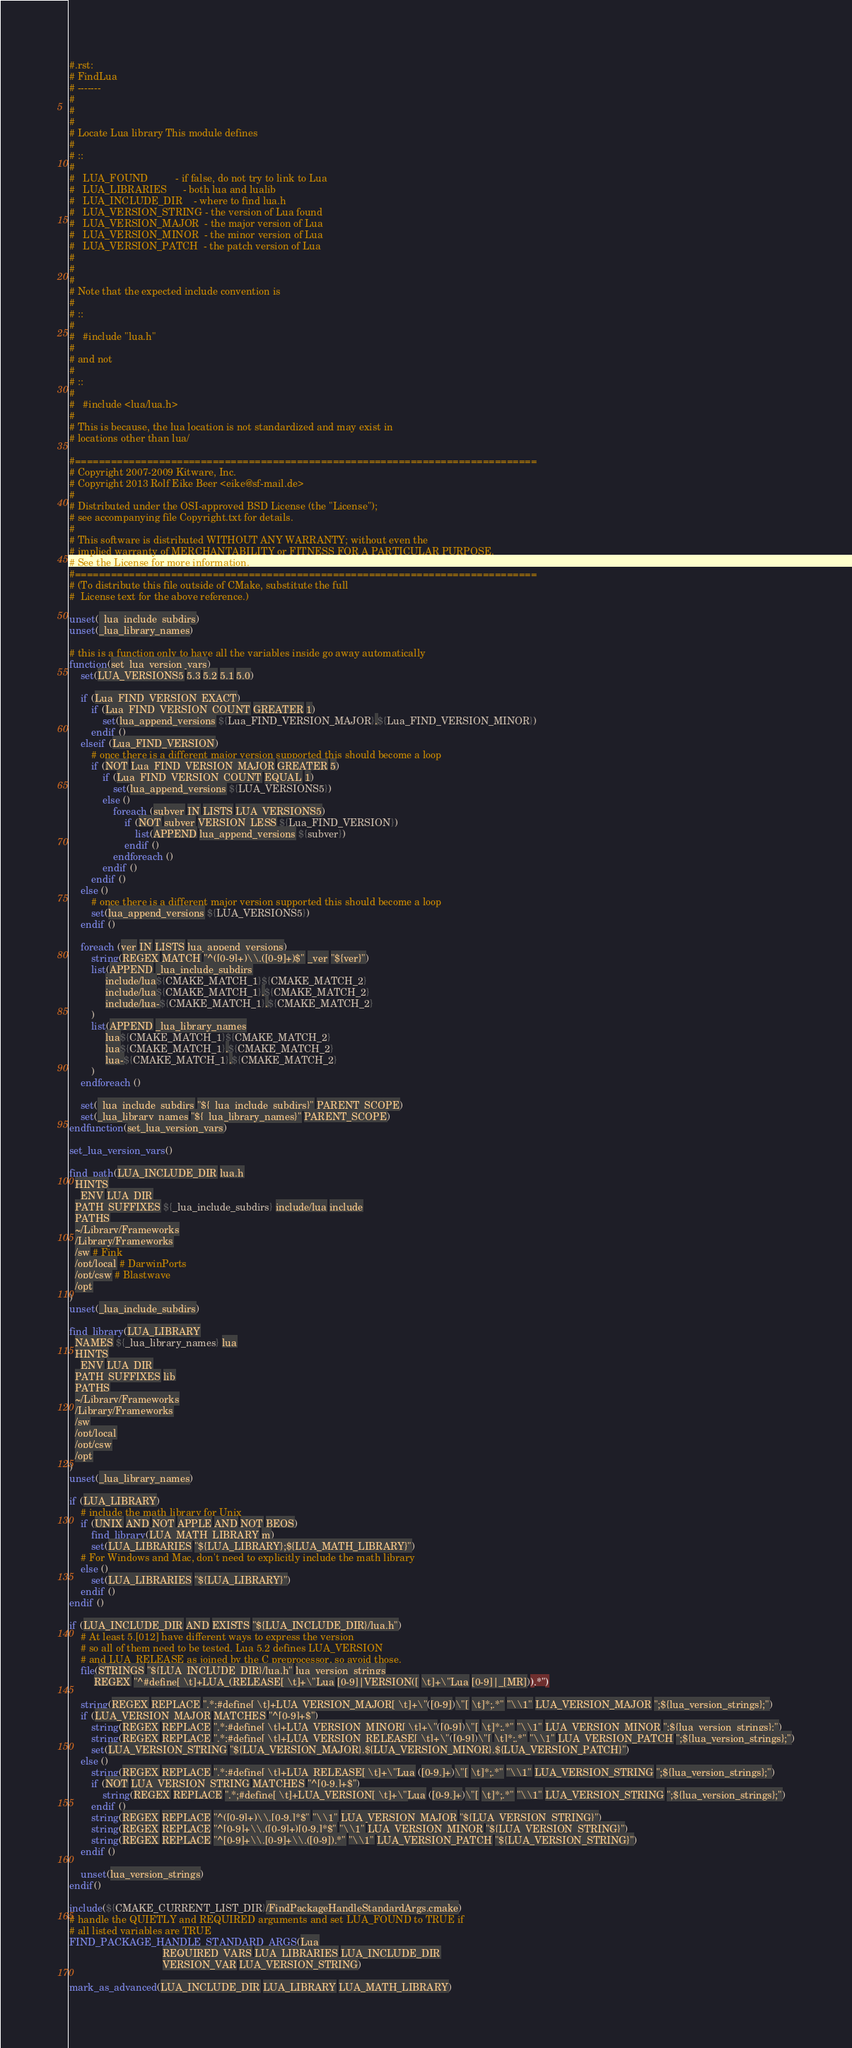Convert code to text. <code><loc_0><loc_0><loc_500><loc_500><_CMake_>#.rst:
# FindLua
# -------
#
#
#
# Locate Lua library This module defines
#
# ::
#
#   LUA_FOUND          - if false, do not try to link to Lua
#   LUA_LIBRARIES      - both lua and lualib
#   LUA_INCLUDE_DIR    - where to find lua.h
#   LUA_VERSION_STRING - the version of Lua found
#   LUA_VERSION_MAJOR  - the major version of Lua
#   LUA_VERSION_MINOR  - the minor version of Lua
#   LUA_VERSION_PATCH  - the patch version of Lua
#
#
#
# Note that the expected include convention is
#
# ::
#
#   #include "lua.h"
#
# and not
#
# ::
#
#   #include <lua/lua.h>
#
# This is because, the lua location is not standardized and may exist in
# locations other than lua/

#=============================================================================
# Copyright 2007-2009 Kitware, Inc.
# Copyright 2013 Rolf Eike Beer <eike@sf-mail.de>
#
# Distributed under the OSI-approved BSD License (the "License");
# see accompanying file Copyright.txt for details.
#
# This software is distributed WITHOUT ANY WARRANTY; without even the
# implied warranty of MERCHANTABILITY or FITNESS FOR A PARTICULAR PURPOSE.
# See the License for more information.
#=============================================================================
# (To distribute this file outside of CMake, substitute the full
#  License text for the above reference.)

unset(_lua_include_subdirs)
unset(_lua_library_names)

# this is a function only to have all the variables inside go away automatically
function(set_lua_version_vars)
    set(LUA_VERSIONS5 5.3 5.2 5.1 5.0)

    if (Lua_FIND_VERSION_EXACT)
        if (Lua_FIND_VERSION_COUNT GREATER 1)
            set(lua_append_versions ${Lua_FIND_VERSION_MAJOR}.${Lua_FIND_VERSION_MINOR})
        endif ()
    elseif (Lua_FIND_VERSION)
        # once there is a different major version supported this should become a loop
        if (NOT Lua_FIND_VERSION_MAJOR GREATER 5)
            if (Lua_FIND_VERSION_COUNT EQUAL 1)
                set(lua_append_versions ${LUA_VERSIONS5})
            else ()
                foreach (subver IN LISTS LUA_VERSIONS5)
                    if (NOT subver VERSION_LESS ${Lua_FIND_VERSION})
                        list(APPEND lua_append_versions ${subver})
                    endif ()
                endforeach ()
            endif ()
        endif ()
    else ()
        # once there is a different major version supported this should become a loop
        set(lua_append_versions ${LUA_VERSIONS5})
    endif ()

    foreach (ver IN LISTS lua_append_versions)
        string(REGEX MATCH "^([0-9]+)\\.([0-9]+)$" _ver "${ver}")
        list(APPEND _lua_include_subdirs
             include/lua${CMAKE_MATCH_1}${CMAKE_MATCH_2}
             include/lua${CMAKE_MATCH_1}.${CMAKE_MATCH_2}
             include/lua-${CMAKE_MATCH_1}.${CMAKE_MATCH_2}
        )
        list(APPEND _lua_library_names
             lua${CMAKE_MATCH_1}${CMAKE_MATCH_2}
             lua${CMAKE_MATCH_1}.${CMAKE_MATCH_2}
             lua-${CMAKE_MATCH_1}.${CMAKE_MATCH_2}
        )
    endforeach ()

    set(_lua_include_subdirs "${_lua_include_subdirs}" PARENT_SCOPE)
    set(_lua_library_names "${_lua_library_names}" PARENT_SCOPE)
endfunction(set_lua_version_vars)

set_lua_version_vars()

find_path(LUA_INCLUDE_DIR lua.h
  HINTS
    ENV LUA_DIR
  PATH_SUFFIXES ${_lua_include_subdirs} include/lua include
  PATHS
  ~/Library/Frameworks
  /Library/Frameworks
  /sw # Fink
  /opt/local # DarwinPorts
  /opt/csw # Blastwave
  /opt
)
unset(_lua_include_subdirs)

find_library(LUA_LIBRARY
  NAMES ${_lua_library_names} lua
  HINTS
    ENV LUA_DIR
  PATH_SUFFIXES lib
  PATHS
  ~/Library/Frameworks
  /Library/Frameworks
  /sw
  /opt/local
  /opt/csw
  /opt
)
unset(_lua_library_names)

if (LUA_LIBRARY)
    # include the math library for Unix
    if (UNIX AND NOT APPLE AND NOT BEOS)
        find_library(LUA_MATH_LIBRARY m)
        set(LUA_LIBRARIES "${LUA_LIBRARY};${LUA_MATH_LIBRARY}")
    # For Windows and Mac, don't need to explicitly include the math library
    else ()
        set(LUA_LIBRARIES "${LUA_LIBRARY}")
    endif ()
endif ()

if (LUA_INCLUDE_DIR AND EXISTS "${LUA_INCLUDE_DIR}/lua.h")
    # At least 5.[012] have different ways to express the version
    # so all of them need to be tested. Lua 5.2 defines LUA_VERSION
    # and LUA_RELEASE as joined by the C preprocessor, so avoid those.
    file(STRINGS "${LUA_INCLUDE_DIR}/lua.h" lua_version_strings
         REGEX "^#define[ \t]+LUA_(RELEASE[ \t]+\"Lua [0-9]|VERSION([ \t]+\"Lua [0-9]|_[MR])).*")

    string(REGEX REPLACE ".*;#define[ \t]+LUA_VERSION_MAJOR[ \t]+\"([0-9])\"[ \t]*;.*" "\\1" LUA_VERSION_MAJOR ";${lua_version_strings};")
    if (LUA_VERSION_MAJOR MATCHES "^[0-9]+$")
        string(REGEX REPLACE ".*;#define[ \t]+LUA_VERSION_MINOR[ \t]+\"([0-9])\"[ \t]*;.*" "\\1" LUA_VERSION_MINOR ";${lua_version_strings};")
        string(REGEX REPLACE ".*;#define[ \t]+LUA_VERSION_RELEASE[ \t]+\"([0-9])\"[ \t]*;.*" "\\1" LUA_VERSION_PATCH ";${lua_version_strings};")
        set(LUA_VERSION_STRING "${LUA_VERSION_MAJOR}.${LUA_VERSION_MINOR}.${LUA_VERSION_PATCH}")
    else ()
        string(REGEX REPLACE ".*;#define[ \t]+LUA_RELEASE[ \t]+\"Lua ([0-9.]+)\"[ \t]*;.*" "\\1" LUA_VERSION_STRING ";${lua_version_strings};")
        if (NOT LUA_VERSION_STRING MATCHES "^[0-9.]+$")
            string(REGEX REPLACE ".*;#define[ \t]+LUA_VERSION[ \t]+\"Lua ([0-9.]+)\"[ \t]*;.*" "\\1" LUA_VERSION_STRING ";${lua_version_strings};")
        endif ()
        string(REGEX REPLACE "^([0-9]+)\\.[0-9.]*$" "\\1" LUA_VERSION_MAJOR "${LUA_VERSION_STRING}")
        string(REGEX REPLACE "^[0-9]+\\.([0-9]+)[0-9.]*$" "\\1" LUA_VERSION_MINOR "${LUA_VERSION_STRING}")
        string(REGEX REPLACE "^[0-9]+\\.[0-9]+\\.([0-9]).*" "\\1" LUA_VERSION_PATCH "${LUA_VERSION_STRING}")
    endif ()

    unset(lua_version_strings)
endif()

include(${CMAKE_CURRENT_LIST_DIR}/FindPackageHandleStandardArgs.cmake)
# handle the QUIETLY and REQUIRED arguments and set LUA_FOUND to TRUE if
# all listed variables are TRUE
FIND_PACKAGE_HANDLE_STANDARD_ARGS(Lua
                                  REQUIRED_VARS LUA_LIBRARIES LUA_INCLUDE_DIR
                                  VERSION_VAR LUA_VERSION_STRING)

mark_as_advanced(LUA_INCLUDE_DIR LUA_LIBRARY LUA_MATH_LIBRARY)

</code> 